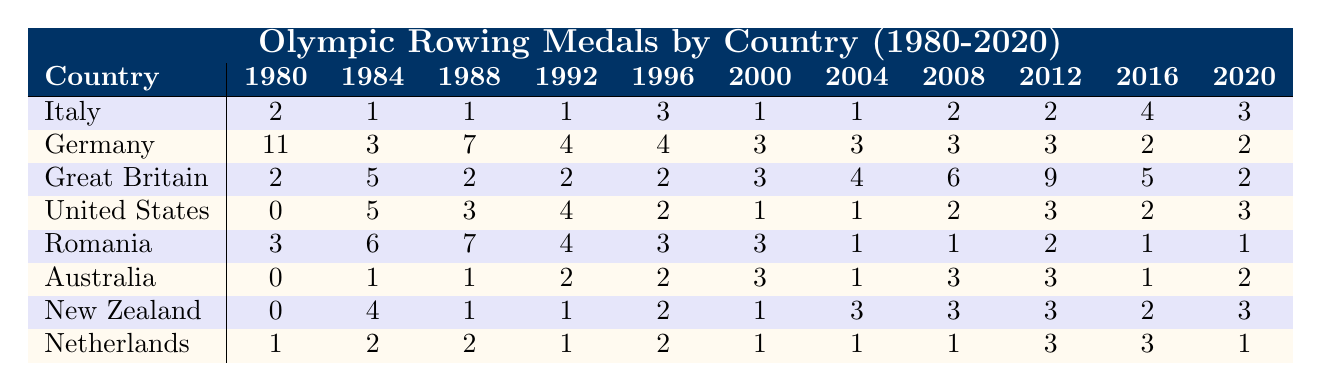What is the total number of medals won by Italy from 1980 to 2020? To find the total number of medals for Italy, we need to sum all the values in the row corresponding to Italy: 2 + 1 + 1 + 1 + 3 + 1 + 1 + 2 + 2 + 4 + 3 = 21
Answer: 21 Which country won the most medals in 1980? Looking at the 1980 column, Germany has the highest number of medals with 11, while the other countries have lower totals.
Answer: Germany What is the average number of medals won by Great Britain from 2000 to 2020? First, we need to sum the values for Great Britain from 2000 to 2020: 3 + 4 + 6 + 9 + 5 + 2 = 29. Then we divide by the number of years, which is 7. So, 29/7 ≈ 4.14.
Answer: 4.14 Did the United States win more than 3 medals in any single Olympic event from 1980 to 2020? By examining the United States row, we see that the highest number in any single event is 5 in 1984; therefore, it is true that they won more than 3 medals in that event.
Answer: Yes Which country had the largest decrease in the number of medals from 1988 to 1992? For each country, we calculate the difference from 1988 to 1992. For Germany: 7 - 4 = 3, for Romania: 7 - 4 = 3, for Italy: 1 - 1 = 0, looking at the others, Australia and Great Britain also had decreases, but not larger than 3. The largest decrease is 3.
Answer: Romania and Germany How many medals did New Zealand win in total across all Olympic events? The total number of medals can be found by summing the values in the New Zealand row: 0 + 4 + 1 + 1 + 2 + 1 + 3 + 3 + 3 + 2 + 3 = 23.
Answer: 23 Was there a year when both Germany and Great Britain won the same number of medals? We check each year: In 2004, both countries won 3 medals, so the claim is true.
Answer: Yes What was the trend of Italy's medals from 1980 to 2020? Analyzing the row for Italy: it started with 2, dipped a bit, had a peak in 2016 with 4, then dropped to 3 in 2020. The general trend seems to fluctuate, with a noticeable peak in 2016.
Answer: Fluctuating with a peak in 2016 How many medals did Germany and Italy win together in 2008? We find the values for both countries in the 2008 column: Germany won 3, and Italy won 2. Summing these gives 3 + 2 = 5 medals total.
Answer: 5 Which country consistently won medals in the Olympics from 1980 to 2020 without ever getting 0? We inspect each row and find that Germany never had a 0 medal total in any year, while other countries (Italy and others) had years they did not medal.
Answer: Germany 